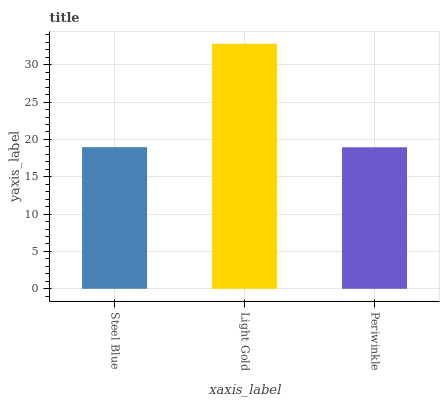Is Periwinkle the minimum?
Answer yes or no. Yes. Is Light Gold the maximum?
Answer yes or no. Yes. Is Light Gold the minimum?
Answer yes or no. No. Is Periwinkle the maximum?
Answer yes or no. No. Is Light Gold greater than Periwinkle?
Answer yes or no. Yes. Is Periwinkle less than Light Gold?
Answer yes or no. Yes. Is Periwinkle greater than Light Gold?
Answer yes or no. No. Is Light Gold less than Periwinkle?
Answer yes or no. No. Is Steel Blue the high median?
Answer yes or no. Yes. Is Steel Blue the low median?
Answer yes or no. Yes. Is Periwinkle the high median?
Answer yes or no. No. Is Periwinkle the low median?
Answer yes or no. No. 